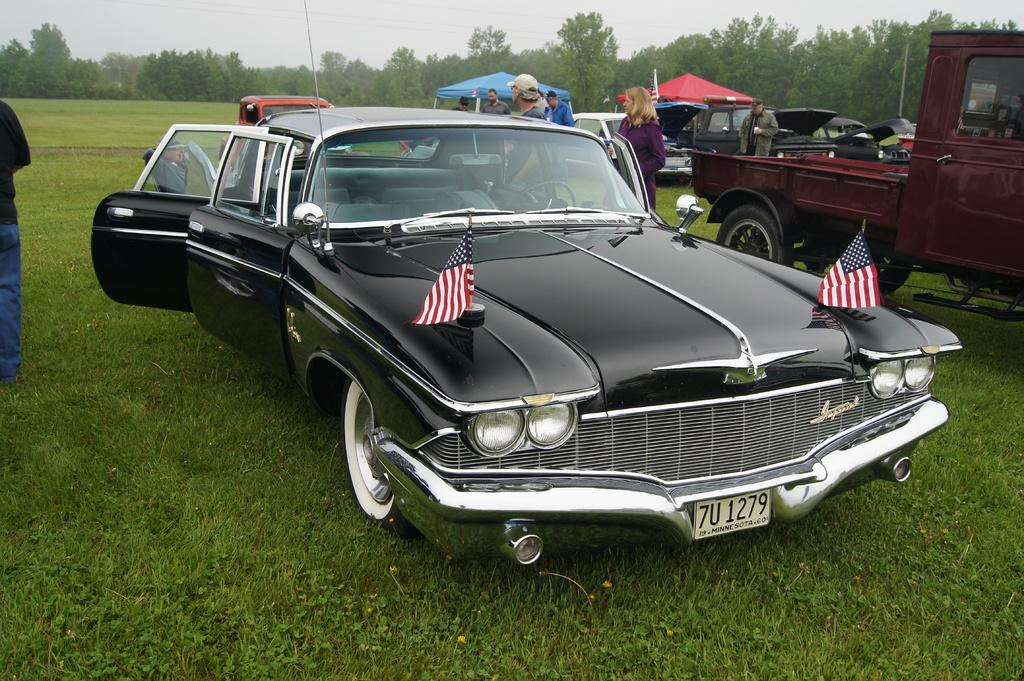What types of objects are present in the image? There are vehicles, people, grass, trees, sky, and tents in the image. Can you describe the setting of the image? The image shows a grassy area with trees and sky in the background, and there are vehicles and tents present. What might the people in the image be doing? The people in the image might be camping, as there are tents present. Can you tell me how many receipts are visible in the image? There are no receipts present in the image. What color is the bead that is hanging from the tree in the image? There is no bead hanging from the tree in the image. 